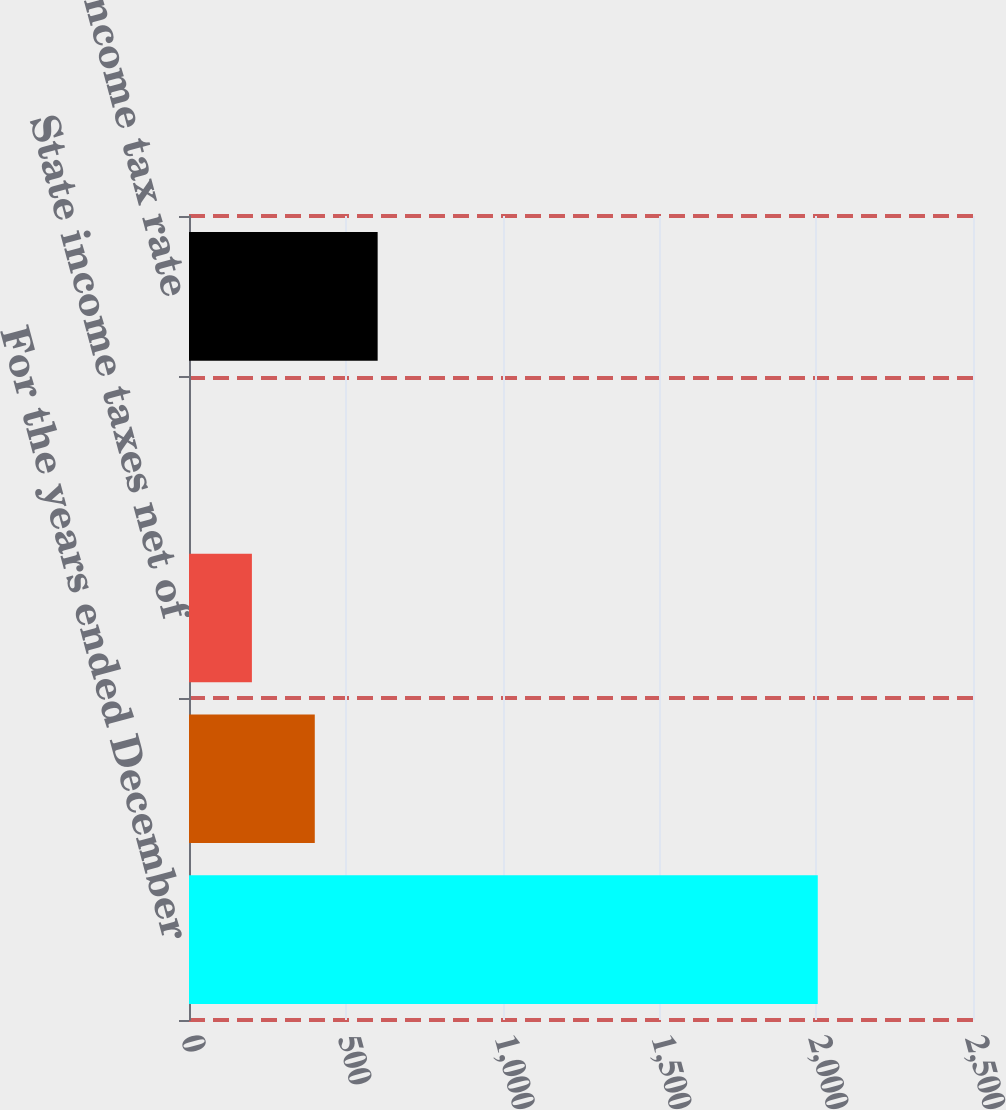Convert chart. <chart><loc_0><loc_0><loc_500><loc_500><bar_chart><fcel>For the years ended December<fcel>Federal statutory income tax<fcel>State income taxes net of<fcel>Other net<fcel>Effective income tax rate<nl><fcel>2005<fcel>401.08<fcel>200.59<fcel>0.1<fcel>601.57<nl></chart> 